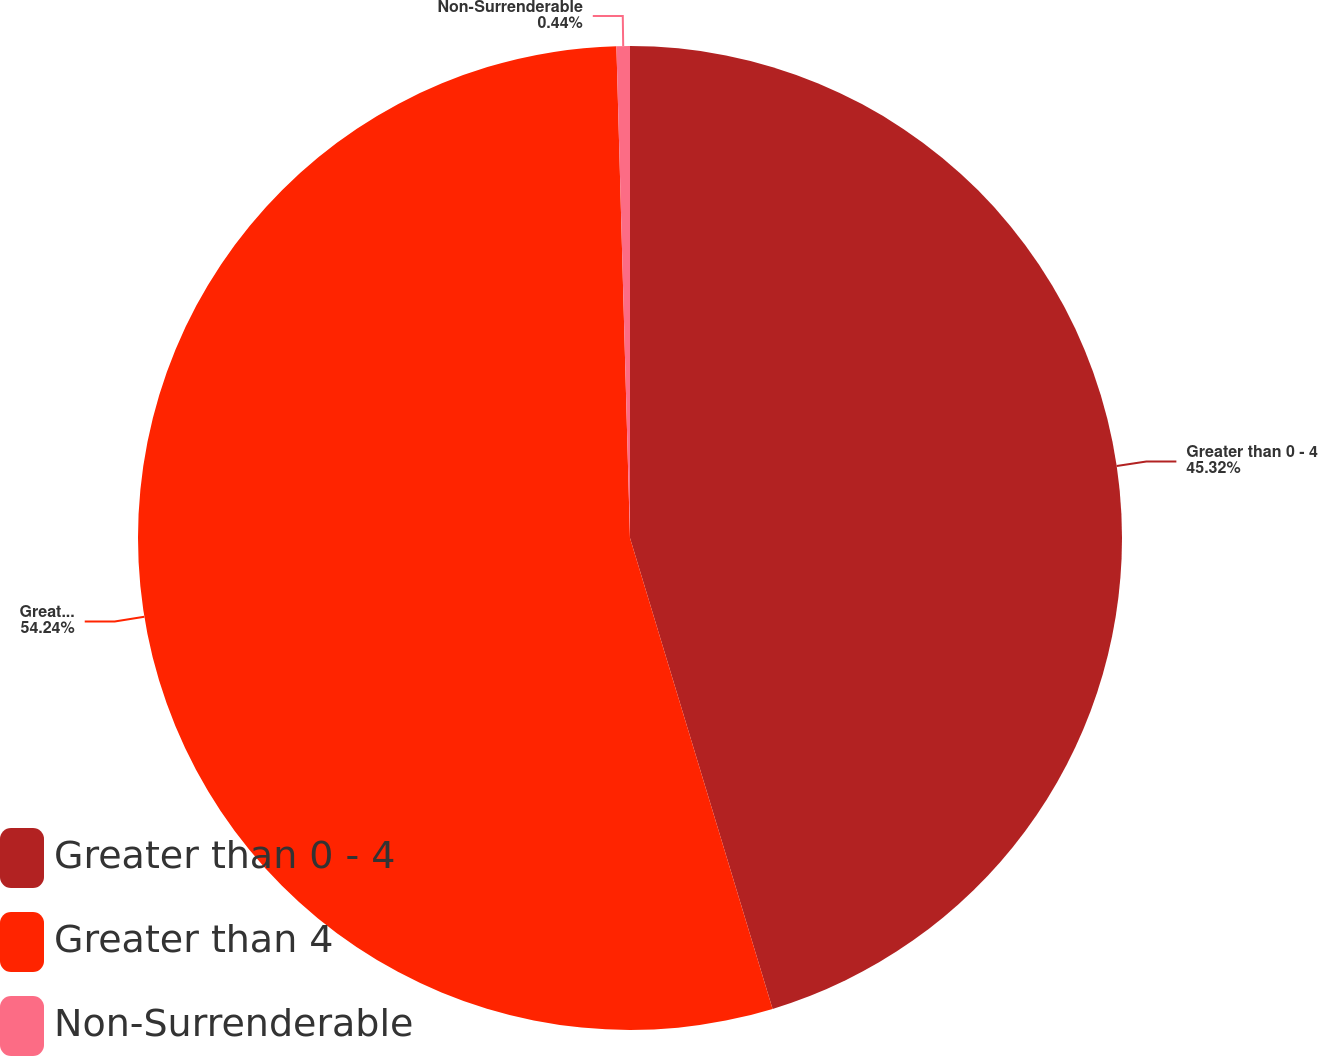Convert chart to OTSL. <chart><loc_0><loc_0><loc_500><loc_500><pie_chart><fcel>Greater than 0 - 4<fcel>Greater than 4<fcel>Non-Surrenderable<nl><fcel>45.32%<fcel>54.24%<fcel>0.44%<nl></chart> 